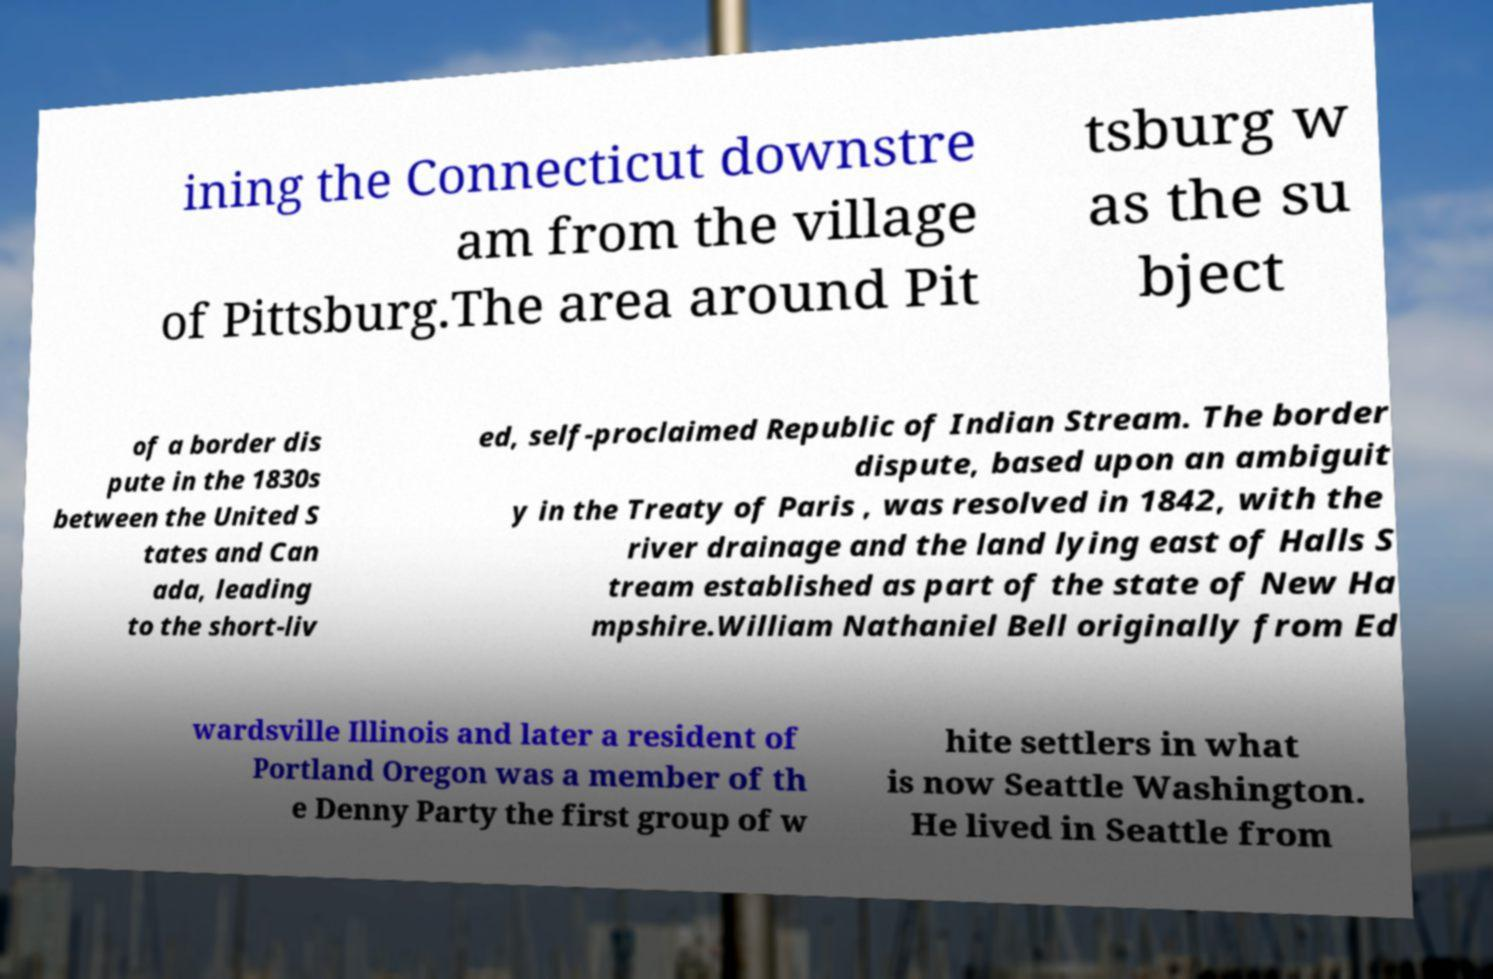What messages or text are displayed in this image? I need them in a readable, typed format. ining the Connecticut downstre am from the village of Pittsburg.The area around Pit tsburg w as the su bject of a border dis pute in the 1830s between the United S tates and Can ada, leading to the short-liv ed, self-proclaimed Republic of Indian Stream. The border dispute, based upon an ambiguit y in the Treaty of Paris , was resolved in 1842, with the river drainage and the land lying east of Halls S tream established as part of the state of New Ha mpshire.William Nathaniel Bell originally from Ed wardsville Illinois and later a resident of Portland Oregon was a member of th e Denny Party the first group of w hite settlers in what is now Seattle Washington. He lived in Seattle from 